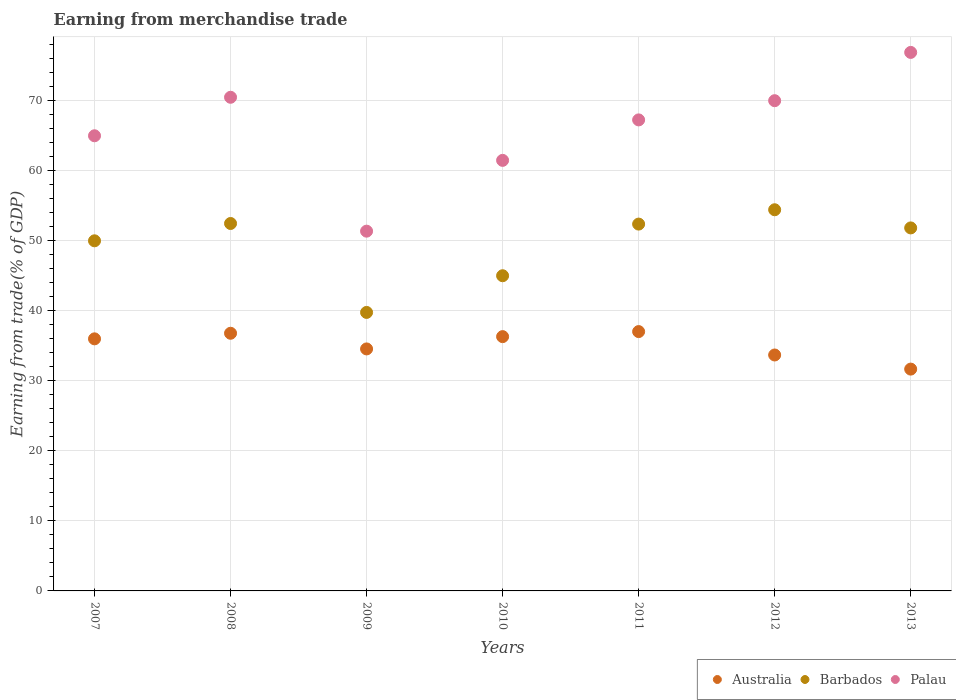How many different coloured dotlines are there?
Ensure brevity in your answer.  3. Is the number of dotlines equal to the number of legend labels?
Your answer should be very brief. Yes. What is the earnings from trade in Barbados in 2012?
Ensure brevity in your answer.  54.36. Across all years, what is the maximum earnings from trade in Barbados?
Provide a short and direct response. 54.36. Across all years, what is the minimum earnings from trade in Palau?
Offer a very short reply. 51.31. What is the total earnings from trade in Australia in the graph?
Provide a short and direct response. 245.76. What is the difference between the earnings from trade in Barbados in 2011 and that in 2012?
Keep it short and to the point. -2.04. What is the difference between the earnings from trade in Australia in 2009 and the earnings from trade in Palau in 2012?
Provide a succinct answer. -35.4. What is the average earnings from trade in Australia per year?
Ensure brevity in your answer.  35.11. In the year 2007, what is the difference between the earnings from trade in Australia and earnings from trade in Barbados?
Your response must be concise. -13.98. In how many years, is the earnings from trade in Palau greater than 48 %?
Ensure brevity in your answer.  7. What is the ratio of the earnings from trade in Palau in 2007 to that in 2011?
Your answer should be compact. 0.97. Is the earnings from trade in Australia in 2008 less than that in 2011?
Your response must be concise. Yes. Is the difference between the earnings from trade in Australia in 2008 and 2010 greater than the difference between the earnings from trade in Barbados in 2008 and 2010?
Your answer should be compact. No. What is the difference between the highest and the second highest earnings from trade in Barbados?
Your answer should be compact. 1.96. What is the difference between the highest and the lowest earnings from trade in Australia?
Make the answer very short. 5.35. Does the earnings from trade in Palau monotonically increase over the years?
Your answer should be compact. No. Is the earnings from trade in Palau strictly greater than the earnings from trade in Australia over the years?
Give a very brief answer. Yes. What is the difference between two consecutive major ticks on the Y-axis?
Make the answer very short. 10. How many legend labels are there?
Your response must be concise. 3. How are the legend labels stacked?
Provide a short and direct response. Horizontal. What is the title of the graph?
Make the answer very short. Earning from merchandise trade. What is the label or title of the Y-axis?
Keep it short and to the point. Earning from trade(% of GDP). What is the Earning from trade(% of GDP) of Australia in 2007?
Your answer should be very brief. 35.95. What is the Earning from trade(% of GDP) of Barbados in 2007?
Make the answer very short. 49.93. What is the Earning from trade(% of GDP) in Palau in 2007?
Your response must be concise. 64.91. What is the Earning from trade(% of GDP) of Australia in 2008?
Provide a short and direct response. 36.75. What is the Earning from trade(% of GDP) of Barbados in 2008?
Offer a very short reply. 52.4. What is the Earning from trade(% of GDP) in Palau in 2008?
Offer a terse response. 70.41. What is the Earning from trade(% of GDP) in Australia in 2009?
Keep it short and to the point. 34.51. What is the Earning from trade(% of GDP) in Barbados in 2009?
Your answer should be very brief. 39.72. What is the Earning from trade(% of GDP) in Palau in 2009?
Ensure brevity in your answer.  51.31. What is the Earning from trade(% of GDP) of Australia in 2010?
Your response must be concise. 36.27. What is the Earning from trade(% of GDP) of Barbados in 2010?
Your answer should be compact. 44.95. What is the Earning from trade(% of GDP) in Palau in 2010?
Ensure brevity in your answer.  61.41. What is the Earning from trade(% of GDP) in Australia in 2011?
Your answer should be very brief. 36.99. What is the Earning from trade(% of GDP) in Barbados in 2011?
Offer a very short reply. 52.32. What is the Earning from trade(% of GDP) in Palau in 2011?
Provide a succinct answer. 67.18. What is the Earning from trade(% of GDP) in Australia in 2012?
Your response must be concise. 33.65. What is the Earning from trade(% of GDP) in Barbados in 2012?
Offer a terse response. 54.36. What is the Earning from trade(% of GDP) of Palau in 2012?
Offer a terse response. 69.92. What is the Earning from trade(% of GDP) in Australia in 2013?
Your response must be concise. 31.64. What is the Earning from trade(% of GDP) of Barbados in 2013?
Your response must be concise. 51.77. What is the Earning from trade(% of GDP) of Palau in 2013?
Offer a terse response. 76.8. Across all years, what is the maximum Earning from trade(% of GDP) of Australia?
Your answer should be compact. 36.99. Across all years, what is the maximum Earning from trade(% of GDP) of Barbados?
Offer a very short reply. 54.36. Across all years, what is the maximum Earning from trade(% of GDP) in Palau?
Keep it short and to the point. 76.8. Across all years, what is the minimum Earning from trade(% of GDP) of Australia?
Offer a very short reply. 31.64. Across all years, what is the minimum Earning from trade(% of GDP) in Barbados?
Your response must be concise. 39.72. Across all years, what is the minimum Earning from trade(% of GDP) in Palau?
Offer a terse response. 51.31. What is the total Earning from trade(% of GDP) of Australia in the graph?
Your response must be concise. 245.76. What is the total Earning from trade(% of GDP) of Barbados in the graph?
Provide a succinct answer. 345.47. What is the total Earning from trade(% of GDP) in Palau in the graph?
Your answer should be compact. 461.94. What is the difference between the Earning from trade(% of GDP) in Australia in 2007 and that in 2008?
Ensure brevity in your answer.  -0.8. What is the difference between the Earning from trade(% of GDP) of Barbados in 2007 and that in 2008?
Give a very brief answer. -2.47. What is the difference between the Earning from trade(% of GDP) in Palau in 2007 and that in 2008?
Your answer should be very brief. -5.49. What is the difference between the Earning from trade(% of GDP) of Australia in 2007 and that in 2009?
Give a very brief answer. 1.44. What is the difference between the Earning from trade(% of GDP) of Barbados in 2007 and that in 2009?
Your response must be concise. 10.21. What is the difference between the Earning from trade(% of GDP) in Palau in 2007 and that in 2009?
Your response must be concise. 13.6. What is the difference between the Earning from trade(% of GDP) of Australia in 2007 and that in 2010?
Keep it short and to the point. -0.32. What is the difference between the Earning from trade(% of GDP) in Barbados in 2007 and that in 2010?
Your response must be concise. 4.98. What is the difference between the Earning from trade(% of GDP) of Palau in 2007 and that in 2010?
Your answer should be very brief. 3.51. What is the difference between the Earning from trade(% of GDP) of Australia in 2007 and that in 2011?
Your answer should be very brief. -1.03. What is the difference between the Earning from trade(% of GDP) in Barbados in 2007 and that in 2011?
Provide a short and direct response. -2.38. What is the difference between the Earning from trade(% of GDP) of Palau in 2007 and that in 2011?
Ensure brevity in your answer.  -2.26. What is the difference between the Earning from trade(% of GDP) in Australia in 2007 and that in 2012?
Provide a short and direct response. 2.3. What is the difference between the Earning from trade(% of GDP) in Barbados in 2007 and that in 2012?
Ensure brevity in your answer.  -4.43. What is the difference between the Earning from trade(% of GDP) in Palau in 2007 and that in 2012?
Offer a terse response. -5. What is the difference between the Earning from trade(% of GDP) in Australia in 2007 and that in 2013?
Offer a terse response. 4.32. What is the difference between the Earning from trade(% of GDP) of Barbados in 2007 and that in 2013?
Offer a terse response. -1.84. What is the difference between the Earning from trade(% of GDP) in Palau in 2007 and that in 2013?
Offer a terse response. -11.89. What is the difference between the Earning from trade(% of GDP) in Australia in 2008 and that in 2009?
Keep it short and to the point. 2.23. What is the difference between the Earning from trade(% of GDP) of Barbados in 2008 and that in 2009?
Your answer should be compact. 12.68. What is the difference between the Earning from trade(% of GDP) of Palau in 2008 and that in 2009?
Offer a terse response. 19.1. What is the difference between the Earning from trade(% of GDP) in Australia in 2008 and that in 2010?
Provide a short and direct response. 0.48. What is the difference between the Earning from trade(% of GDP) in Barbados in 2008 and that in 2010?
Ensure brevity in your answer.  7.45. What is the difference between the Earning from trade(% of GDP) of Palau in 2008 and that in 2010?
Your response must be concise. 9. What is the difference between the Earning from trade(% of GDP) of Australia in 2008 and that in 2011?
Your response must be concise. -0.24. What is the difference between the Earning from trade(% of GDP) in Barbados in 2008 and that in 2011?
Keep it short and to the point. 0.09. What is the difference between the Earning from trade(% of GDP) in Palau in 2008 and that in 2011?
Provide a succinct answer. 3.23. What is the difference between the Earning from trade(% of GDP) in Australia in 2008 and that in 2012?
Make the answer very short. 3.1. What is the difference between the Earning from trade(% of GDP) of Barbados in 2008 and that in 2012?
Your answer should be compact. -1.96. What is the difference between the Earning from trade(% of GDP) of Palau in 2008 and that in 2012?
Offer a very short reply. 0.49. What is the difference between the Earning from trade(% of GDP) in Australia in 2008 and that in 2013?
Your answer should be very brief. 5.11. What is the difference between the Earning from trade(% of GDP) of Barbados in 2008 and that in 2013?
Your answer should be compact. 0.63. What is the difference between the Earning from trade(% of GDP) of Palau in 2008 and that in 2013?
Your answer should be compact. -6.4. What is the difference between the Earning from trade(% of GDP) in Australia in 2009 and that in 2010?
Your answer should be very brief. -1.75. What is the difference between the Earning from trade(% of GDP) in Barbados in 2009 and that in 2010?
Your answer should be compact. -5.23. What is the difference between the Earning from trade(% of GDP) of Palau in 2009 and that in 2010?
Give a very brief answer. -10.1. What is the difference between the Earning from trade(% of GDP) of Australia in 2009 and that in 2011?
Ensure brevity in your answer.  -2.47. What is the difference between the Earning from trade(% of GDP) of Barbados in 2009 and that in 2011?
Your answer should be compact. -12.6. What is the difference between the Earning from trade(% of GDP) in Palau in 2009 and that in 2011?
Your response must be concise. -15.87. What is the difference between the Earning from trade(% of GDP) in Australia in 2009 and that in 2012?
Provide a short and direct response. 0.86. What is the difference between the Earning from trade(% of GDP) in Barbados in 2009 and that in 2012?
Ensure brevity in your answer.  -14.64. What is the difference between the Earning from trade(% of GDP) of Palau in 2009 and that in 2012?
Ensure brevity in your answer.  -18.61. What is the difference between the Earning from trade(% of GDP) in Australia in 2009 and that in 2013?
Make the answer very short. 2.88. What is the difference between the Earning from trade(% of GDP) in Barbados in 2009 and that in 2013?
Give a very brief answer. -12.05. What is the difference between the Earning from trade(% of GDP) of Palau in 2009 and that in 2013?
Ensure brevity in your answer.  -25.49. What is the difference between the Earning from trade(% of GDP) of Australia in 2010 and that in 2011?
Provide a short and direct response. -0.72. What is the difference between the Earning from trade(% of GDP) in Barbados in 2010 and that in 2011?
Give a very brief answer. -7.37. What is the difference between the Earning from trade(% of GDP) of Palau in 2010 and that in 2011?
Make the answer very short. -5.77. What is the difference between the Earning from trade(% of GDP) of Australia in 2010 and that in 2012?
Your answer should be compact. 2.62. What is the difference between the Earning from trade(% of GDP) in Barbados in 2010 and that in 2012?
Offer a very short reply. -9.41. What is the difference between the Earning from trade(% of GDP) of Palau in 2010 and that in 2012?
Your answer should be compact. -8.51. What is the difference between the Earning from trade(% of GDP) in Australia in 2010 and that in 2013?
Give a very brief answer. 4.63. What is the difference between the Earning from trade(% of GDP) of Barbados in 2010 and that in 2013?
Provide a succinct answer. -6.82. What is the difference between the Earning from trade(% of GDP) of Palau in 2010 and that in 2013?
Your response must be concise. -15.4. What is the difference between the Earning from trade(% of GDP) in Australia in 2011 and that in 2012?
Give a very brief answer. 3.34. What is the difference between the Earning from trade(% of GDP) of Barbados in 2011 and that in 2012?
Provide a succinct answer. -2.04. What is the difference between the Earning from trade(% of GDP) of Palau in 2011 and that in 2012?
Your answer should be compact. -2.74. What is the difference between the Earning from trade(% of GDP) in Australia in 2011 and that in 2013?
Your answer should be compact. 5.35. What is the difference between the Earning from trade(% of GDP) in Barbados in 2011 and that in 2013?
Offer a very short reply. 0.55. What is the difference between the Earning from trade(% of GDP) in Palau in 2011 and that in 2013?
Offer a terse response. -9.63. What is the difference between the Earning from trade(% of GDP) of Australia in 2012 and that in 2013?
Your answer should be very brief. 2.01. What is the difference between the Earning from trade(% of GDP) of Barbados in 2012 and that in 2013?
Offer a terse response. 2.59. What is the difference between the Earning from trade(% of GDP) of Palau in 2012 and that in 2013?
Keep it short and to the point. -6.89. What is the difference between the Earning from trade(% of GDP) in Australia in 2007 and the Earning from trade(% of GDP) in Barbados in 2008?
Your response must be concise. -16.45. What is the difference between the Earning from trade(% of GDP) in Australia in 2007 and the Earning from trade(% of GDP) in Palau in 2008?
Provide a short and direct response. -34.45. What is the difference between the Earning from trade(% of GDP) in Barbados in 2007 and the Earning from trade(% of GDP) in Palau in 2008?
Your response must be concise. -20.47. What is the difference between the Earning from trade(% of GDP) in Australia in 2007 and the Earning from trade(% of GDP) in Barbados in 2009?
Offer a very short reply. -3.77. What is the difference between the Earning from trade(% of GDP) in Australia in 2007 and the Earning from trade(% of GDP) in Palau in 2009?
Give a very brief answer. -15.36. What is the difference between the Earning from trade(% of GDP) of Barbados in 2007 and the Earning from trade(% of GDP) of Palau in 2009?
Provide a short and direct response. -1.38. What is the difference between the Earning from trade(% of GDP) of Australia in 2007 and the Earning from trade(% of GDP) of Barbados in 2010?
Ensure brevity in your answer.  -9. What is the difference between the Earning from trade(% of GDP) in Australia in 2007 and the Earning from trade(% of GDP) in Palau in 2010?
Offer a very short reply. -25.46. What is the difference between the Earning from trade(% of GDP) in Barbados in 2007 and the Earning from trade(% of GDP) in Palau in 2010?
Keep it short and to the point. -11.47. What is the difference between the Earning from trade(% of GDP) of Australia in 2007 and the Earning from trade(% of GDP) of Barbados in 2011?
Keep it short and to the point. -16.37. What is the difference between the Earning from trade(% of GDP) in Australia in 2007 and the Earning from trade(% of GDP) in Palau in 2011?
Your answer should be very brief. -31.23. What is the difference between the Earning from trade(% of GDP) of Barbados in 2007 and the Earning from trade(% of GDP) of Palau in 2011?
Provide a short and direct response. -17.24. What is the difference between the Earning from trade(% of GDP) in Australia in 2007 and the Earning from trade(% of GDP) in Barbados in 2012?
Offer a terse response. -18.41. What is the difference between the Earning from trade(% of GDP) of Australia in 2007 and the Earning from trade(% of GDP) of Palau in 2012?
Offer a very short reply. -33.97. What is the difference between the Earning from trade(% of GDP) in Barbados in 2007 and the Earning from trade(% of GDP) in Palau in 2012?
Your answer should be compact. -19.98. What is the difference between the Earning from trade(% of GDP) of Australia in 2007 and the Earning from trade(% of GDP) of Barbados in 2013?
Offer a very short reply. -15.82. What is the difference between the Earning from trade(% of GDP) of Australia in 2007 and the Earning from trade(% of GDP) of Palau in 2013?
Your answer should be compact. -40.85. What is the difference between the Earning from trade(% of GDP) of Barbados in 2007 and the Earning from trade(% of GDP) of Palau in 2013?
Provide a succinct answer. -26.87. What is the difference between the Earning from trade(% of GDP) of Australia in 2008 and the Earning from trade(% of GDP) of Barbados in 2009?
Your answer should be very brief. -2.97. What is the difference between the Earning from trade(% of GDP) in Australia in 2008 and the Earning from trade(% of GDP) in Palau in 2009?
Give a very brief answer. -14.56. What is the difference between the Earning from trade(% of GDP) of Barbados in 2008 and the Earning from trade(% of GDP) of Palau in 2009?
Your response must be concise. 1.09. What is the difference between the Earning from trade(% of GDP) of Australia in 2008 and the Earning from trade(% of GDP) of Barbados in 2010?
Your answer should be compact. -8.21. What is the difference between the Earning from trade(% of GDP) in Australia in 2008 and the Earning from trade(% of GDP) in Palau in 2010?
Offer a terse response. -24.66. What is the difference between the Earning from trade(% of GDP) of Barbados in 2008 and the Earning from trade(% of GDP) of Palau in 2010?
Your answer should be very brief. -9. What is the difference between the Earning from trade(% of GDP) in Australia in 2008 and the Earning from trade(% of GDP) in Barbados in 2011?
Ensure brevity in your answer.  -15.57. What is the difference between the Earning from trade(% of GDP) in Australia in 2008 and the Earning from trade(% of GDP) in Palau in 2011?
Ensure brevity in your answer.  -30.43. What is the difference between the Earning from trade(% of GDP) in Barbados in 2008 and the Earning from trade(% of GDP) in Palau in 2011?
Offer a terse response. -14.77. What is the difference between the Earning from trade(% of GDP) in Australia in 2008 and the Earning from trade(% of GDP) in Barbados in 2012?
Ensure brevity in your answer.  -17.62. What is the difference between the Earning from trade(% of GDP) of Australia in 2008 and the Earning from trade(% of GDP) of Palau in 2012?
Your response must be concise. -33.17. What is the difference between the Earning from trade(% of GDP) of Barbados in 2008 and the Earning from trade(% of GDP) of Palau in 2012?
Your answer should be very brief. -17.51. What is the difference between the Earning from trade(% of GDP) of Australia in 2008 and the Earning from trade(% of GDP) of Barbados in 2013?
Ensure brevity in your answer.  -15.03. What is the difference between the Earning from trade(% of GDP) of Australia in 2008 and the Earning from trade(% of GDP) of Palau in 2013?
Your answer should be very brief. -40.06. What is the difference between the Earning from trade(% of GDP) of Barbados in 2008 and the Earning from trade(% of GDP) of Palau in 2013?
Ensure brevity in your answer.  -24.4. What is the difference between the Earning from trade(% of GDP) of Australia in 2009 and the Earning from trade(% of GDP) of Barbados in 2010?
Ensure brevity in your answer.  -10.44. What is the difference between the Earning from trade(% of GDP) in Australia in 2009 and the Earning from trade(% of GDP) in Palau in 2010?
Your response must be concise. -26.89. What is the difference between the Earning from trade(% of GDP) of Barbados in 2009 and the Earning from trade(% of GDP) of Palau in 2010?
Make the answer very short. -21.69. What is the difference between the Earning from trade(% of GDP) of Australia in 2009 and the Earning from trade(% of GDP) of Barbados in 2011?
Your response must be concise. -17.8. What is the difference between the Earning from trade(% of GDP) in Australia in 2009 and the Earning from trade(% of GDP) in Palau in 2011?
Give a very brief answer. -32.66. What is the difference between the Earning from trade(% of GDP) of Barbados in 2009 and the Earning from trade(% of GDP) of Palau in 2011?
Make the answer very short. -27.46. What is the difference between the Earning from trade(% of GDP) in Australia in 2009 and the Earning from trade(% of GDP) in Barbados in 2012?
Ensure brevity in your answer.  -19.85. What is the difference between the Earning from trade(% of GDP) of Australia in 2009 and the Earning from trade(% of GDP) of Palau in 2012?
Give a very brief answer. -35.4. What is the difference between the Earning from trade(% of GDP) of Barbados in 2009 and the Earning from trade(% of GDP) of Palau in 2012?
Provide a succinct answer. -30.2. What is the difference between the Earning from trade(% of GDP) of Australia in 2009 and the Earning from trade(% of GDP) of Barbados in 2013?
Make the answer very short. -17.26. What is the difference between the Earning from trade(% of GDP) in Australia in 2009 and the Earning from trade(% of GDP) in Palau in 2013?
Ensure brevity in your answer.  -42.29. What is the difference between the Earning from trade(% of GDP) of Barbados in 2009 and the Earning from trade(% of GDP) of Palau in 2013?
Your response must be concise. -37.08. What is the difference between the Earning from trade(% of GDP) in Australia in 2010 and the Earning from trade(% of GDP) in Barbados in 2011?
Provide a succinct answer. -16.05. What is the difference between the Earning from trade(% of GDP) of Australia in 2010 and the Earning from trade(% of GDP) of Palau in 2011?
Your answer should be very brief. -30.91. What is the difference between the Earning from trade(% of GDP) in Barbados in 2010 and the Earning from trade(% of GDP) in Palau in 2011?
Ensure brevity in your answer.  -22.23. What is the difference between the Earning from trade(% of GDP) in Australia in 2010 and the Earning from trade(% of GDP) in Barbados in 2012?
Provide a succinct answer. -18.1. What is the difference between the Earning from trade(% of GDP) of Australia in 2010 and the Earning from trade(% of GDP) of Palau in 2012?
Your response must be concise. -33.65. What is the difference between the Earning from trade(% of GDP) of Barbados in 2010 and the Earning from trade(% of GDP) of Palau in 2012?
Provide a short and direct response. -24.97. What is the difference between the Earning from trade(% of GDP) in Australia in 2010 and the Earning from trade(% of GDP) in Barbados in 2013?
Ensure brevity in your answer.  -15.51. What is the difference between the Earning from trade(% of GDP) in Australia in 2010 and the Earning from trade(% of GDP) in Palau in 2013?
Your answer should be compact. -40.54. What is the difference between the Earning from trade(% of GDP) in Barbados in 2010 and the Earning from trade(% of GDP) in Palau in 2013?
Provide a succinct answer. -31.85. What is the difference between the Earning from trade(% of GDP) in Australia in 2011 and the Earning from trade(% of GDP) in Barbados in 2012?
Keep it short and to the point. -17.38. What is the difference between the Earning from trade(% of GDP) of Australia in 2011 and the Earning from trade(% of GDP) of Palau in 2012?
Keep it short and to the point. -32.93. What is the difference between the Earning from trade(% of GDP) of Barbados in 2011 and the Earning from trade(% of GDP) of Palau in 2012?
Your response must be concise. -17.6. What is the difference between the Earning from trade(% of GDP) in Australia in 2011 and the Earning from trade(% of GDP) in Barbados in 2013?
Your answer should be compact. -14.79. What is the difference between the Earning from trade(% of GDP) in Australia in 2011 and the Earning from trade(% of GDP) in Palau in 2013?
Ensure brevity in your answer.  -39.82. What is the difference between the Earning from trade(% of GDP) of Barbados in 2011 and the Earning from trade(% of GDP) of Palau in 2013?
Offer a very short reply. -24.49. What is the difference between the Earning from trade(% of GDP) of Australia in 2012 and the Earning from trade(% of GDP) of Barbados in 2013?
Ensure brevity in your answer.  -18.12. What is the difference between the Earning from trade(% of GDP) in Australia in 2012 and the Earning from trade(% of GDP) in Palau in 2013?
Give a very brief answer. -43.15. What is the difference between the Earning from trade(% of GDP) in Barbados in 2012 and the Earning from trade(% of GDP) in Palau in 2013?
Your response must be concise. -22.44. What is the average Earning from trade(% of GDP) in Australia per year?
Provide a short and direct response. 35.11. What is the average Earning from trade(% of GDP) in Barbados per year?
Provide a succinct answer. 49.35. What is the average Earning from trade(% of GDP) of Palau per year?
Provide a succinct answer. 65.99. In the year 2007, what is the difference between the Earning from trade(% of GDP) of Australia and Earning from trade(% of GDP) of Barbados?
Provide a succinct answer. -13.98. In the year 2007, what is the difference between the Earning from trade(% of GDP) of Australia and Earning from trade(% of GDP) of Palau?
Your answer should be compact. -28.96. In the year 2007, what is the difference between the Earning from trade(% of GDP) in Barbados and Earning from trade(% of GDP) in Palau?
Keep it short and to the point. -14.98. In the year 2008, what is the difference between the Earning from trade(% of GDP) in Australia and Earning from trade(% of GDP) in Barbados?
Make the answer very short. -15.66. In the year 2008, what is the difference between the Earning from trade(% of GDP) in Australia and Earning from trade(% of GDP) in Palau?
Provide a succinct answer. -33.66. In the year 2008, what is the difference between the Earning from trade(% of GDP) in Barbados and Earning from trade(% of GDP) in Palau?
Offer a very short reply. -18. In the year 2009, what is the difference between the Earning from trade(% of GDP) in Australia and Earning from trade(% of GDP) in Barbados?
Provide a succinct answer. -5.21. In the year 2009, what is the difference between the Earning from trade(% of GDP) in Australia and Earning from trade(% of GDP) in Palau?
Provide a succinct answer. -16.8. In the year 2009, what is the difference between the Earning from trade(% of GDP) in Barbados and Earning from trade(% of GDP) in Palau?
Offer a terse response. -11.59. In the year 2010, what is the difference between the Earning from trade(% of GDP) in Australia and Earning from trade(% of GDP) in Barbados?
Provide a short and direct response. -8.69. In the year 2010, what is the difference between the Earning from trade(% of GDP) of Australia and Earning from trade(% of GDP) of Palau?
Offer a very short reply. -25.14. In the year 2010, what is the difference between the Earning from trade(% of GDP) of Barbados and Earning from trade(% of GDP) of Palau?
Keep it short and to the point. -16.45. In the year 2011, what is the difference between the Earning from trade(% of GDP) in Australia and Earning from trade(% of GDP) in Barbados?
Your answer should be very brief. -15.33. In the year 2011, what is the difference between the Earning from trade(% of GDP) of Australia and Earning from trade(% of GDP) of Palau?
Make the answer very short. -30.19. In the year 2011, what is the difference between the Earning from trade(% of GDP) in Barbados and Earning from trade(% of GDP) in Palau?
Your answer should be compact. -14.86. In the year 2012, what is the difference between the Earning from trade(% of GDP) in Australia and Earning from trade(% of GDP) in Barbados?
Your answer should be compact. -20.71. In the year 2012, what is the difference between the Earning from trade(% of GDP) in Australia and Earning from trade(% of GDP) in Palau?
Your answer should be very brief. -36.27. In the year 2012, what is the difference between the Earning from trade(% of GDP) in Barbados and Earning from trade(% of GDP) in Palau?
Offer a terse response. -15.56. In the year 2013, what is the difference between the Earning from trade(% of GDP) of Australia and Earning from trade(% of GDP) of Barbados?
Your answer should be compact. -20.14. In the year 2013, what is the difference between the Earning from trade(% of GDP) of Australia and Earning from trade(% of GDP) of Palau?
Offer a very short reply. -45.17. In the year 2013, what is the difference between the Earning from trade(% of GDP) in Barbados and Earning from trade(% of GDP) in Palau?
Provide a short and direct response. -25.03. What is the ratio of the Earning from trade(% of GDP) of Australia in 2007 to that in 2008?
Ensure brevity in your answer.  0.98. What is the ratio of the Earning from trade(% of GDP) of Barbados in 2007 to that in 2008?
Your answer should be compact. 0.95. What is the ratio of the Earning from trade(% of GDP) of Palau in 2007 to that in 2008?
Offer a terse response. 0.92. What is the ratio of the Earning from trade(% of GDP) of Australia in 2007 to that in 2009?
Keep it short and to the point. 1.04. What is the ratio of the Earning from trade(% of GDP) of Barbados in 2007 to that in 2009?
Offer a terse response. 1.26. What is the ratio of the Earning from trade(% of GDP) of Palau in 2007 to that in 2009?
Provide a short and direct response. 1.27. What is the ratio of the Earning from trade(% of GDP) of Australia in 2007 to that in 2010?
Ensure brevity in your answer.  0.99. What is the ratio of the Earning from trade(% of GDP) in Barbados in 2007 to that in 2010?
Your response must be concise. 1.11. What is the ratio of the Earning from trade(% of GDP) of Palau in 2007 to that in 2010?
Offer a terse response. 1.06. What is the ratio of the Earning from trade(% of GDP) in Barbados in 2007 to that in 2011?
Your response must be concise. 0.95. What is the ratio of the Earning from trade(% of GDP) in Palau in 2007 to that in 2011?
Your answer should be very brief. 0.97. What is the ratio of the Earning from trade(% of GDP) of Australia in 2007 to that in 2012?
Your answer should be very brief. 1.07. What is the ratio of the Earning from trade(% of GDP) in Barbados in 2007 to that in 2012?
Your answer should be very brief. 0.92. What is the ratio of the Earning from trade(% of GDP) in Palau in 2007 to that in 2012?
Your response must be concise. 0.93. What is the ratio of the Earning from trade(% of GDP) in Australia in 2007 to that in 2013?
Keep it short and to the point. 1.14. What is the ratio of the Earning from trade(% of GDP) in Barbados in 2007 to that in 2013?
Offer a very short reply. 0.96. What is the ratio of the Earning from trade(% of GDP) in Palau in 2007 to that in 2013?
Provide a succinct answer. 0.85. What is the ratio of the Earning from trade(% of GDP) in Australia in 2008 to that in 2009?
Give a very brief answer. 1.06. What is the ratio of the Earning from trade(% of GDP) in Barbados in 2008 to that in 2009?
Provide a succinct answer. 1.32. What is the ratio of the Earning from trade(% of GDP) in Palau in 2008 to that in 2009?
Provide a short and direct response. 1.37. What is the ratio of the Earning from trade(% of GDP) in Australia in 2008 to that in 2010?
Keep it short and to the point. 1.01. What is the ratio of the Earning from trade(% of GDP) in Barbados in 2008 to that in 2010?
Your answer should be compact. 1.17. What is the ratio of the Earning from trade(% of GDP) of Palau in 2008 to that in 2010?
Ensure brevity in your answer.  1.15. What is the ratio of the Earning from trade(% of GDP) of Palau in 2008 to that in 2011?
Provide a short and direct response. 1.05. What is the ratio of the Earning from trade(% of GDP) of Australia in 2008 to that in 2012?
Your response must be concise. 1.09. What is the ratio of the Earning from trade(% of GDP) in Australia in 2008 to that in 2013?
Give a very brief answer. 1.16. What is the ratio of the Earning from trade(% of GDP) of Barbados in 2008 to that in 2013?
Your response must be concise. 1.01. What is the ratio of the Earning from trade(% of GDP) of Palau in 2008 to that in 2013?
Give a very brief answer. 0.92. What is the ratio of the Earning from trade(% of GDP) in Australia in 2009 to that in 2010?
Give a very brief answer. 0.95. What is the ratio of the Earning from trade(% of GDP) of Barbados in 2009 to that in 2010?
Provide a succinct answer. 0.88. What is the ratio of the Earning from trade(% of GDP) of Palau in 2009 to that in 2010?
Make the answer very short. 0.84. What is the ratio of the Earning from trade(% of GDP) in Australia in 2009 to that in 2011?
Offer a terse response. 0.93. What is the ratio of the Earning from trade(% of GDP) in Barbados in 2009 to that in 2011?
Give a very brief answer. 0.76. What is the ratio of the Earning from trade(% of GDP) of Palau in 2009 to that in 2011?
Offer a terse response. 0.76. What is the ratio of the Earning from trade(% of GDP) in Australia in 2009 to that in 2012?
Your response must be concise. 1.03. What is the ratio of the Earning from trade(% of GDP) in Barbados in 2009 to that in 2012?
Provide a succinct answer. 0.73. What is the ratio of the Earning from trade(% of GDP) of Palau in 2009 to that in 2012?
Provide a succinct answer. 0.73. What is the ratio of the Earning from trade(% of GDP) of Australia in 2009 to that in 2013?
Your answer should be very brief. 1.09. What is the ratio of the Earning from trade(% of GDP) in Barbados in 2009 to that in 2013?
Offer a terse response. 0.77. What is the ratio of the Earning from trade(% of GDP) of Palau in 2009 to that in 2013?
Your answer should be compact. 0.67. What is the ratio of the Earning from trade(% of GDP) in Australia in 2010 to that in 2011?
Offer a terse response. 0.98. What is the ratio of the Earning from trade(% of GDP) in Barbados in 2010 to that in 2011?
Make the answer very short. 0.86. What is the ratio of the Earning from trade(% of GDP) in Palau in 2010 to that in 2011?
Your response must be concise. 0.91. What is the ratio of the Earning from trade(% of GDP) in Australia in 2010 to that in 2012?
Offer a very short reply. 1.08. What is the ratio of the Earning from trade(% of GDP) in Barbados in 2010 to that in 2012?
Your response must be concise. 0.83. What is the ratio of the Earning from trade(% of GDP) of Palau in 2010 to that in 2012?
Your answer should be compact. 0.88. What is the ratio of the Earning from trade(% of GDP) of Australia in 2010 to that in 2013?
Offer a very short reply. 1.15. What is the ratio of the Earning from trade(% of GDP) of Barbados in 2010 to that in 2013?
Provide a short and direct response. 0.87. What is the ratio of the Earning from trade(% of GDP) in Palau in 2010 to that in 2013?
Your answer should be very brief. 0.8. What is the ratio of the Earning from trade(% of GDP) in Australia in 2011 to that in 2012?
Provide a succinct answer. 1.1. What is the ratio of the Earning from trade(% of GDP) of Barbados in 2011 to that in 2012?
Provide a succinct answer. 0.96. What is the ratio of the Earning from trade(% of GDP) in Palau in 2011 to that in 2012?
Ensure brevity in your answer.  0.96. What is the ratio of the Earning from trade(% of GDP) of Australia in 2011 to that in 2013?
Provide a short and direct response. 1.17. What is the ratio of the Earning from trade(% of GDP) in Barbados in 2011 to that in 2013?
Offer a terse response. 1.01. What is the ratio of the Earning from trade(% of GDP) in Palau in 2011 to that in 2013?
Your answer should be very brief. 0.87. What is the ratio of the Earning from trade(% of GDP) of Australia in 2012 to that in 2013?
Offer a terse response. 1.06. What is the ratio of the Earning from trade(% of GDP) of Barbados in 2012 to that in 2013?
Provide a succinct answer. 1.05. What is the ratio of the Earning from trade(% of GDP) of Palau in 2012 to that in 2013?
Your response must be concise. 0.91. What is the difference between the highest and the second highest Earning from trade(% of GDP) in Australia?
Provide a succinct answer. 0.24. What is the difference between the highest and the second highest Earning from trade(% of GDP) of Barbados?
Keep it short and to the point. 1.96. What is the difference between the highest and the second highest Earning from trade(% of GDP) of Palau?
Offer a very short reply. 6.4. What is the difference between the highest and the lowest Earning from trade(% of GDP) in Australia?
Offer a terse response. 5.35. What is the difference between the highest and the lowest Earning from trade(% of GDP) of Barbados?
Provide a succinct answer. 14.64. What is the difference between the highest and the lowest Earning from trade(% of GDP) in Palau?
Offer a terse response. 25.49. 